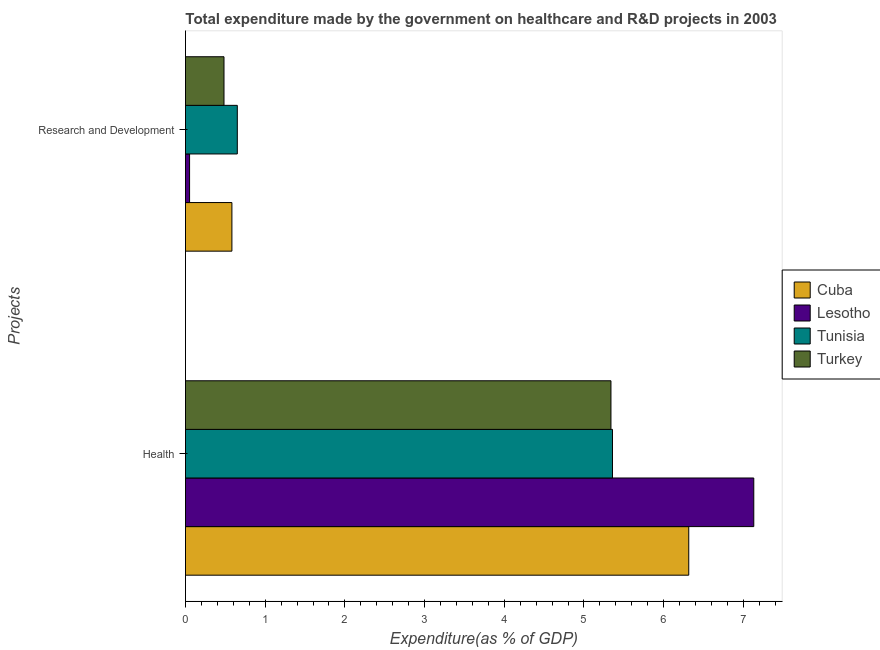How many different coloured bars are there?
Provide a succinct answer. 4. Are the number of bars per tick equal to the number of legend labels?
Give a very brief answer. Yes. What is the label of the 1st group of bars from the top?
Your answer should be very brief. Research and Development. What is the expenditure in healthcare in Turkey?
Provide a short and direct response. 5.34. Across all countries, what is the maximum expenditure in healthcare?
Your answer should be very brief. 7.13. Across all countries, what is the minimum expenditure in r&d?
Your answer should be compact. 0.05. In which country was the expenditure in healthcare maximum?
Provide a short and direct response. Lesotho. In which country was the expenditure in healthcare minimum?
Make the answer very short. Turkey. What is the total expenditure in r&d in the graph?
Your answer should be very brief. 1.77. What is the difference between the expenditure in healthcare in Tunisia and that in Lesotho?
Offer a very short reply. -1.77. What is the difference between the expenditure in healthcare in Cuba and the expenditure in r&d in Lesotho?
Ensure brevity in your answer.  6.26. What is the average expenditure in r&d per country?
Provide a short and direct response. 0.44. What is the difference between the expenditure in healthcare and expenditure in r&d in Cuba?
Provide a short and direct response. 5.73. What is the ratio of the expenditure in healthcare in Cuba to that in Lesotho?
Ensure brevity in your answer.  0.89. Is the expenditure in r&d in Lesotho less than that in Turkey?
Ensure brevity in your answer.  Yes. In how many countries, is the expenditure in r&d greater than the average expenditure in r&d taken over all countries?
Ensure brevity in your answer.  3. What does the 2nd bar from the top in Health represents?
Offer a terse response. Tunisia. What does the 2nd bar from the bottom in Research and Development represents?
Keep it short and to the point. Lesotho. How many bars are there?
Make the answer very short. 8. Are all the bars in the graph horizontal?
Keep it short and to the point. Yes. How many countries are there in the graph?
Offer a terse response. 4. Does the graph contain any zero values?
Your response must be concise. No. Where does the legend appear in the graph?
Make the answer very short. Center right. How many legend labels are there?
Make the answer very short. 4. How are the legend labels stacked?
Your answer should be very brief. Vertical. What is the title of the graph?
Give a very brief answer. Total expenditure made by the government on healthcare and R&D projects in 2003. What is the label or title of the X-axis?
Offer a terse response. Expenditure(as % of GDP). What is the label or title of the Y-axis?
Keep it short and to the point. Projects. What is the Expenditure(as % of GDP) in Cuba in Health?
Give a very brief answer. 6.31. What is the Expenditure(as % of GDP) of Lesotho in Health?
Your answer should be compact. 7.13. What is the Expenditure(as % of GDP) in Tunisia in Health?
Ensure brevity in your answer.  5.36. What is the Expenditure(as % of GDP) of Turkey in Health?
Provide a succinct answer. 5.34. What is the Expenditure(as % of GDP) in Cuba in Research and Development?
Provide a succinct answer. 0.58. What is the Expenditure(as % of GDP) of Lesotho in Research and Development?
Keep it short and to the point. 0.05. What is the Expenditure(as % of GDP) of Tunisia in Research and Development?
Make the answer very short. 0.65. What is the Expenditure(as % of GDP) of Turkey in Research and Development?
Provide a succinct answer. 0.48. Across all Projects, what is the maximum Expenditure(as % of GDP) in Cuba?
Offer a terse response. 6.31. Across all Projects, what is the maximum Expenditure(as % of GDP) of Lesotho?
Provide a short and direct response. 7.13. Across all Projects, what is the maximum Expenditure(as % of GDP) of Tunisia?
Ensure brevity in your answer.  5.36. Across all Projects, what is the maximum Expenditure(as % of GDP) in Turkey?
Your answer should be compact. 5.34. Across all Projects, what is the minimum Expenditure(as % of GDP) in Cuba?
Provide a succinct answer. 0.58. Across all Projects, what is the minimum Expenditure(as % of GDP) of Lesotho?
Provide a short and direct response. 0.05. Across all Projects, what is the minimum Expenditure(as % of GDP) of Tunisia?
Ensure brevity in your answer.  0.65. Across all Projects, what is the minimum Expenditure(as % of GDP) in Turkey?
Offer a very short reply. 0.48. What is the total Expenditure(as % of GDP) in Cuba in the graph?
Offer a very short reply. 6.9. What is the total Expenditure(as % of GDP) in Lesotho in the graph?
Your answer should be compact. 7.18. What is the total Expenditure(as % of GDP) in Tunisia in the graph?
Give a very brief answer. 6.01. What is the total Expenditure(as % of GDP) of Turkey in the graph?
Offer a very short reply. 5.82. What is the difference between the Expenditure(as % of GDP) of Cuba in Health and that in Research and Development?
Provide a succinct answer. 5.73. What is the difference between the Expenditure(as % of GDP) of Lesotho in Health and that in Research and Development?
Provide a succinct answer. 7.08. What is the difference between the Expenditure(as % of GDP) of Tunisia in Health and that in Research and Development?
Your response must be concise. 4.71. What is the difference between the Expenditure(as % of GDP) in Turkey in Health and that in Research and Development?
Ensure brevity in your answer.  4.86. What is the difference between the Expenditure(as % of GDP) in Cuba in Health and the Expenditure(as % of GDP) in Lesotho in Research and Development?
Keep it short and to the point. 6.26. What is the difference between the Expenditure(as % of GDP) of Cuba in Health and the Expenditure(as % of GDP) of Tunisia in Research and Development?
Offer a terse response. 5.66. What is the difference between the Expenditure(as % of GDP) of Cuba in Health and the Expenditure(as % of GDP) of Turkey in Research and Development?
Make the answer very short. 5.83. What is the difference between the Expenditure(as % of GDP) of Lesotho in Health and the Expenditure(as % of GDP) of Tunisia in Research and Development?
Give a very brief answer. 6.48. What is the difference between the Expenditure(as % of GDP) of Lesotho in Health and the Expenditure(as % of GDP) of Turkey in Research and Development?
Offer a terse response. 6.65. What is the difference between the Expenditure(as % of GDP) of Tunisia in Health and the Expenditure(as % of GDP) of Turkey in Research and Development?
Offer a terse response. 4.87. What is the average Expenditure(as % of GDP) of Cuba per Projects?
Your answer should be compact. 3.45. What is the average Expenditure(as % of GDP) in Lesotho per Projects?
Keep it short and to the point. 3.59. What is the average Expenditure(as % of GDP) in Tunisia per Projects?
Ensure brevity in your answer.  3. What is the average Expenditure(as % of GDP) in Turkey per Projects?
Your response must be concise. 2.91. What is the difference between the Expenditure(as % of GDP) of Cuba and Expenditure(as % of GDP) of Lesotho in Health?
Provide a short and direct response. -0.82. What is the difference between the Expenditure(as % of GDP) of Cuba and Expenditure(as % of GDP) of Tunisia in Health?
Give a very brief answer. 0.96. What is the difference between the Expenditure(as % of GDP) in Cuba and Expenditure(as % of GDP) in Turkey in Health?
Your response must be concise. 0.98. What is the difference between the Expenditure(as % of GDP) in Lesotho and Expenditure(as % of GDP) in Tunisia in Health?
Provide a short and direct response. 1.77. What is the difference between the Expenditure(as % of GDP) in Lesotho and Expenditure(as % of GDP) in Turkey in Health?
Offer a terse response. 1.79. What is the difference between the Expenditure(as % of GDP) of Tunisia and Expenditure(as % of GDP) of Turkey in Health?
Make the answer very short. 0.02. What is the difference between the Expenditure(as % of GDP) in Cuba and Expenditure(as % of GDP) in Lesotho in Research and Development?
Ensure brevity in your answer.  0.53. What is the difference between the Expenditure(as % of GDP) of Cuba and Expenditure(as % of GDP) of Tunisia in Research and Development?
Ensure brevity in your answer.  -0.07. What is the difference between the Expenditure(as % of GDP) in Cuba and Expenditure(as % of GDP) in Turkey in Research and Development?
Your answer should be compact. 0.1. What is the difference between the Expenditure(as % of GDP) in Lesotho and Expenditure(as % of GDP) in Tunisia in Research and Development?
Ensure brevity in your answer.  -0.6. What is the difference between the Expenditure(as % of GDP) in Lesotho and Expenditure(as % of GDP) in Turkey in Research and Development?
Provide a succinct answer. -0.43. What is the difference between the Expenditure(as % of GDP) in Tunisia and Expenditure(as % of GDP) in Turkey in Research and Development?
Offer a very short reply. 0.17. What is the ratio of the Expenditure(as % of GDP) of Cuba in Health to that in Research and Development?
Offer a terse response. 10.84. What is the ratio of the Expenditure(as % of GDP) of Lesotho in Health to that in Research and Development?
Offer a very short reply. 138.98. What is the ratio of the Expenditure(as % of GDP) of Tunisia in Health to that in Research and Development?
Make the answer very short. 8.24. What is the ratio of the Expenditure(as % of GDP) of Turkey in Health to that in Research and Development?
Provide a succinct answer. 11.05. What is the difference between the highest and the second highest Expenditure(as % of GDP) of Cuba?
Give a very brief answer. 5.73. What is the difference between the highest and the second highest Expenditure(as % of GDP) of Lesotho?
Offer a very short reply. 7.08. What is the difference between the highest and the second highest Expenditure(as % of GDP) in Tunisia?
Your answer should be very brief. 4.71. What is the difference between the highest and the second highest Expenditure(as % of GDP) of Turkey?
Offer a very short reply. 4.86. What is the difference between the highest and the lowest Expenditure(as % of GDP) of Cuba?
Give a very brief answer. 5.73. What is the difference between the highest and the lowest Expenditure(as % of GDP) of Lesotho?
Ensure brevity in your answer.  7.08. What is the difference between the highest and the lowest Expenditure(as % of GDP) of Tunisia?
Ensure brevity in your answer.  4.71. What is the difference between the highest and the lowest Expenditure(as % of GDP) of Turkey?
Your response must be concise. 4.86. 